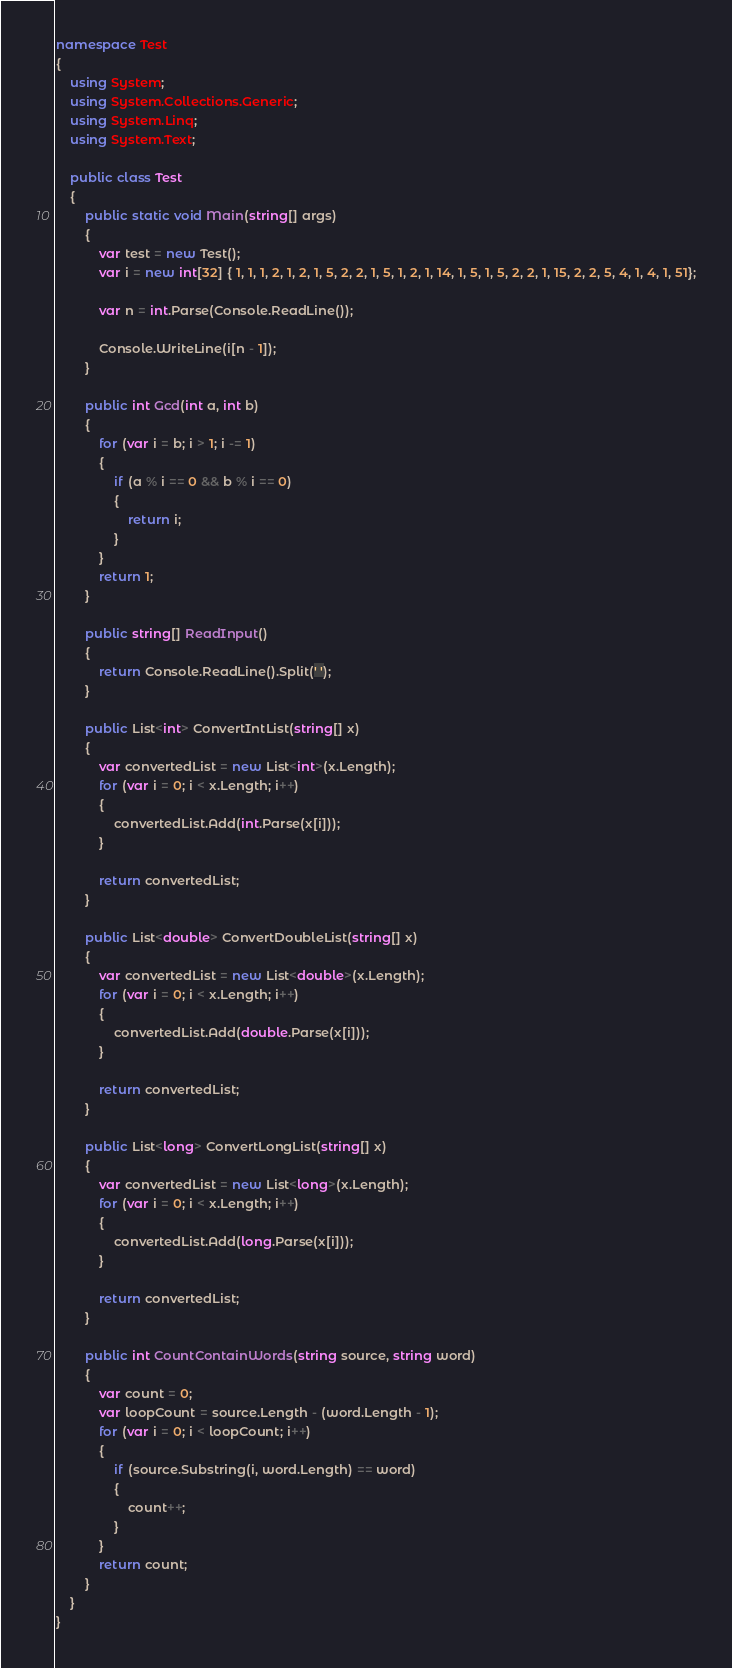Convert code to text. <code><loc_0><loc_0><loc_500><loc_500><_C#_>namespace Test
{
    using System;
    using System.Collections.Generic;
    using System.Linq;
    using System.Text;

    public class Test
    {
        public static void Main(string[] args)
        {
            var test = new Test();
            var i = new int[32] { 1, 1, 1, 2, 1, 2, 1, 5, 2, 2, 1, 5, 1, 2, 1, 14, 1, 5, 1, 5, 2, 2, 1, 15, 2, 2, 5, 4, 1, 4, 1, 51};

            var n = int.Parse(Console.ReadLine());
            
            Console.WriteLine(i[n - 1]);
        }

        public int Gcd(int a, int b)
        {
            for (var i = b; i > 1; i -= 1)
            {
                if (a % i == 0 && b % i == 0)
                {
                    return i;
                }
            }
            return 1;
        }

        public string[] ReadInput()
        {
            return Console.ReadLine().Split(' ');
        }

        public List<int> ConvertIntList(string[] x)
        {
            var convertedList = new List<int>(x.Length);
            for (var i = 0; i < x.Length; i++)
            {
                convertedList.Add(int.Parse(x[i]));
            }

            return convertedList;
        }

        public List<double> ConvertDoubleList(string[] x)
        {
            var convertedList = new List<double>(x.Length);
            for (var i = 0; i < x.Length; i++)
            {
                convertedList.Add(double.Parse(x[i]));
            }

            return convertedList;
        }

        public List<long> ConvertLongList(string[] x)
        {
            var convertedList = new List<long>(x.Length);
            for (var i = 0; i < x.Length; i++)
            {
                convertedList.Add(long.Parse(x[i]));
            }

            return convertedList;
        }

        public int CountContainWords(string source, string word)
        {
            var count = 0;
            var loopCount = source.Length - (word.Length - 1);
            for (var i = 0; i < loopCount; i++)
            {
                if (source.Substring(i, word.Length) == word)
                {
                    count++;
                }
            }
            return count;
        }
    }
}</code> 